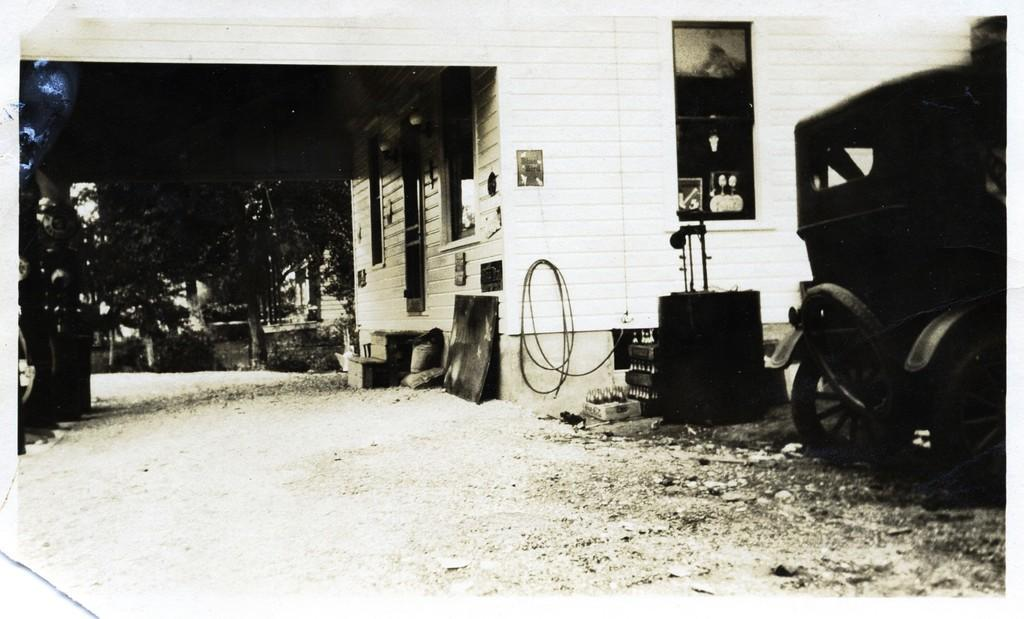What type of structure is present in the image? There is a house in the image. What can be seen beside the house? There are objects beside the house. What feature of the house is visible in the image? There are windows visible in the image. What type of vegetation is present in the image? There are trees in the image. What is located on the right side of the image? There are objects on the right side of the image. What is the yak thinking about in the image? There is no yak present in the image, so it cannot be determined what the yak might be thinking about. 